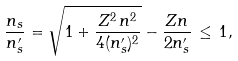<formula> <loc_0><loc_0><loc_500><loc_500>\frac { n _ { s } } { n ^ { \prime } _ { s } } = \sqrt { 1 + \frac { Z ^ { 2 } \, n ^ { 2 } } { 4 ( n ^ { \prime } _ { s } ) ^ { 2 } } } - \frac { Z n } { 2 n ^ { \prime } _ { s } } \, \leq \, 1 ,</formula> 